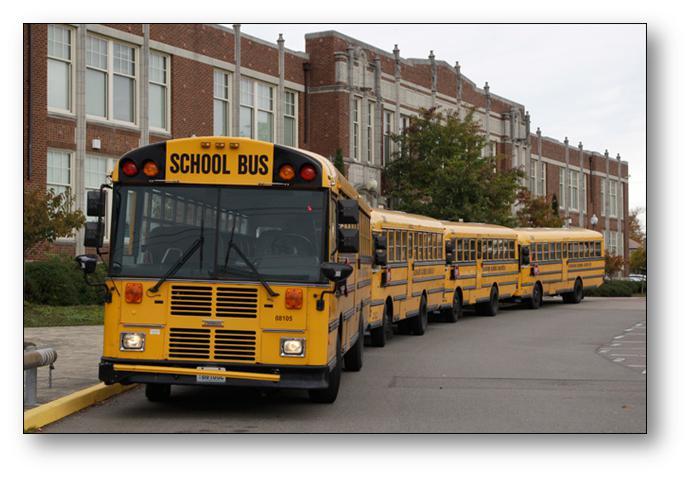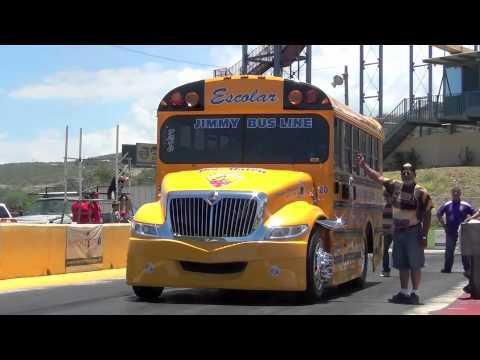The first image is the image on the left, the second image is the image on the right. Considering the images on both sides, is "One bus has wheels on its roof." valid? Answer yes or no. No. The first image is the image on the left, the second image is the image on the right. Given the left and right images, does the statement "The right image shows a sideways short bus with not more than three rectangular passenger windows, and the left image shows a bus with an inverted bus on its top." hold true? Answer yes or no. No. 